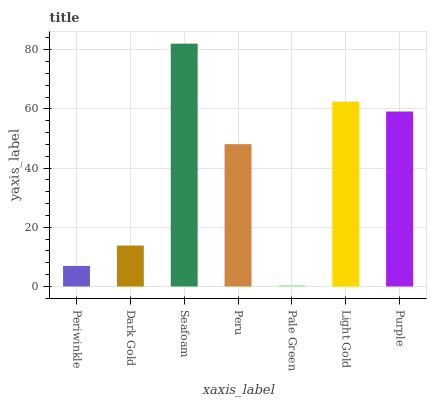Is Pale Green the minimum?
Answer yes or no. Yes. Is Seafoam the maximum?
Answer yes or no. Yes. Is Dark Gold the minimum?
Answer yes or no. No. Is Dark Gold the maximum?
Answer yes or no. No. Is Dark Gold greater than Periwinkle?
Answer yes or no. Yes. Is Periwinkle less than Dark Gold?
Answer yes or no. Yes. Is Periwinkle greater than Dark Gold?
Answer yes or no. No. Is Dark Gold less than Periwinkle?
Answer yes or no. No. Is Peru the high median?
Answer yes or no. Yes. Is Peru the low median?
Answer yes or no. Yes. Is Light Gold the high median?
Answer yes or no. No. Is Seafoam the low median?
Answer yes or no. No. 